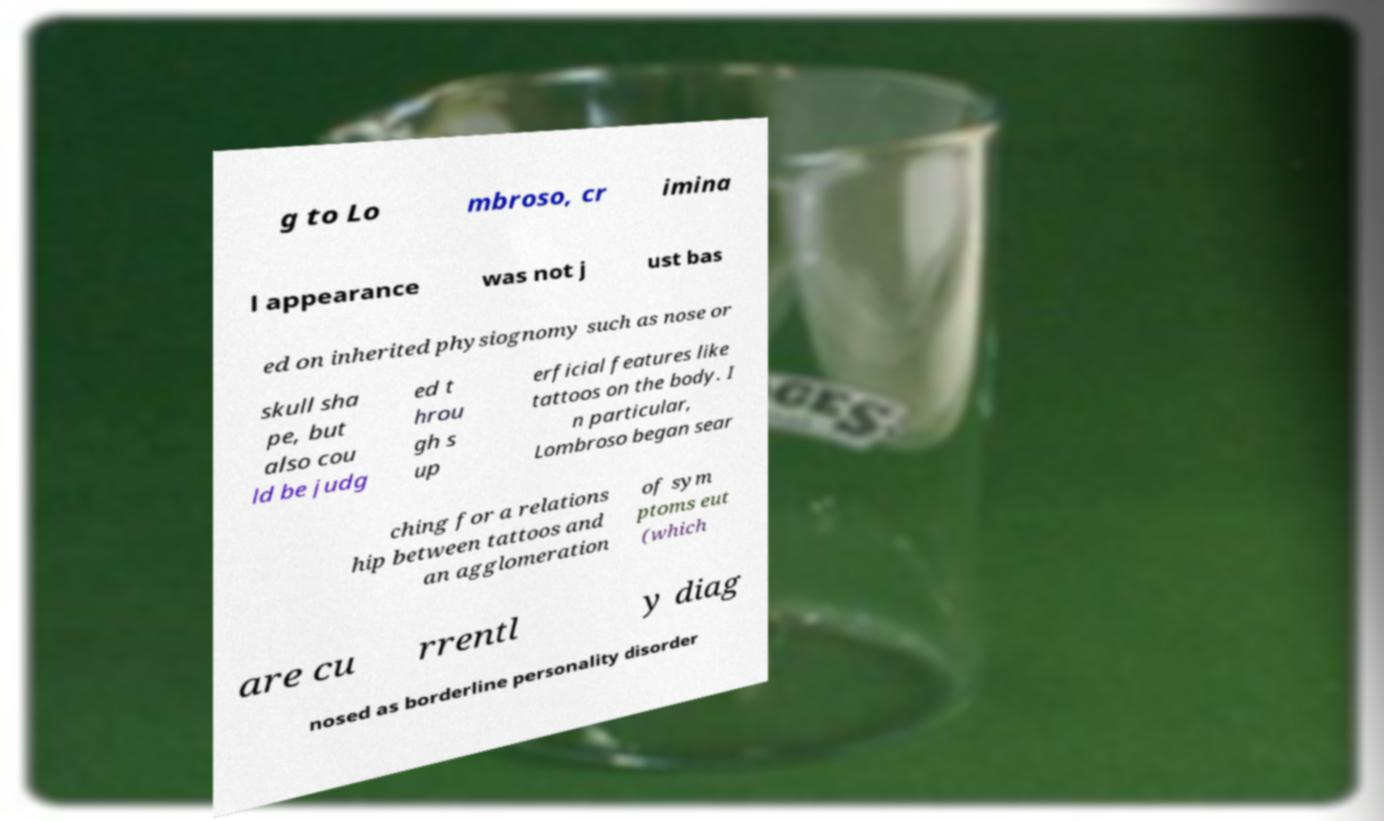Could you extract and type out the text from this image? g to Lo mbroso, cr imina l appearance was not j ust bas ed on inherited physiognomy such as nose or skull sha pe, but also cou ld be judg ed t hrou gh s up erficial features like tattoos on the body. I n particular, Lombroso began sear ching for a relations hip between tattoos and an agglomeration of sym ptoms eut (which are cu rrentl y diag nosed as borderline personality disorder 